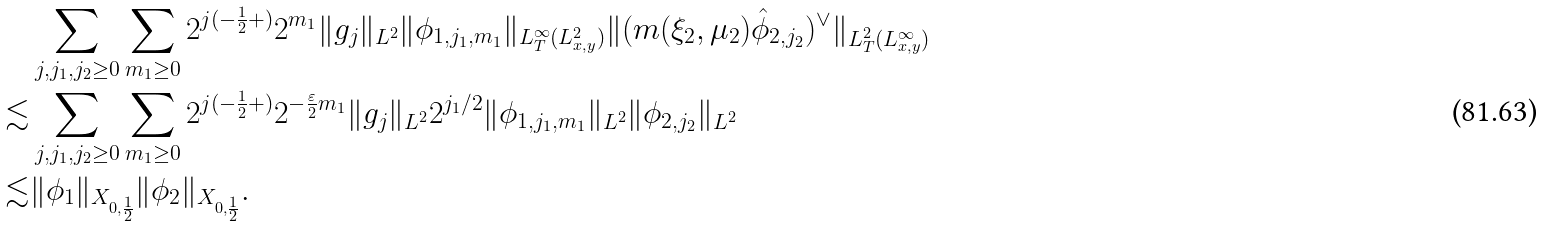Convert formula to latex. <formula><loc_0><loc_0><loc_500><loc_500>& \sum _ { j , j _ { 1 } , j _ { 2 } \geq 0 } \sum _ { m _ { 1 } \geq 0 } 2 ^ { j ( - \frac { 1 } { 2 } + ) } 2 ^ { m _ { 1 } } \| g _ { j } \| _ { L ^ { 2 } } \| \phi _ { 1 , j _ { 1 } , m _ { 1 } } \| _ { L ^ { \infty } _ { T } ( L ^ { 2 } _ { x , y } ) } \| ( m ( \xi _ { 2 } , \mu _ { 2 } ) \hat { \phi } _ { 2 , j _ { 2 } } ) ^ { \vee } \| _ { L ^ { 2 } _ { T } ( L ^ { \infty } _ { x , y } ) } \\ \lesssim & \sum _ { j , j _ { 1 } , j _ { 2 } \geq 0 } \sum _ { m _ { 1 } \geq 0 } 2 ^ { j ( - \frac { 1 } { 2 } + ) } 2 ^ { - \frac { \varepsilon } { 2 } m _ { 1 } } \| g _ { j } \| _ { L ^ { 2 } } 2 ^ { j _ { 1 } / 2 } \| \phi _ { 1 , j _ { 1 } , m _ { 1 } } \| _ { L ^ { 2 } } \| \phi _ { 2 , j _ { 2 } } \| _ { L ^ { 2 } } \\ \lesssim & \| \phi _ { 1 } \| _ { X _ { 0 , \frac { 1 } { 2 } } } \| \phi _ { 2 } \| _ { X _ { 0 , \frac { 1 } { 2 } } } .</formula> 